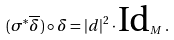<formula> <loc_0><loc_0><loc_500><loc_500>( \sigma ^ { * } \overline { \delta } ) \circ \delta = | d | ^ { 2 } \cdot \text {Id} _ { M } \, .</formula> 